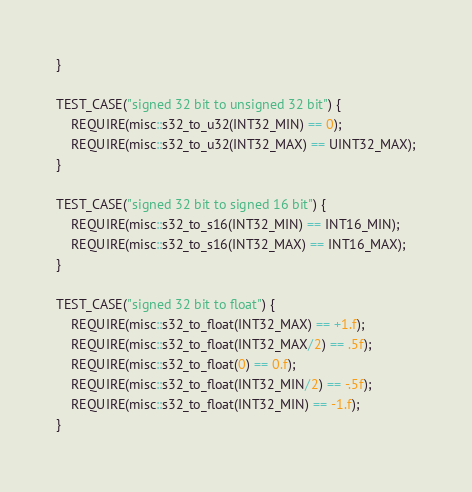<code> <loc_0><loc_0><loc_500><loc_500><_C++_>}

TEST_CASE("signed 32 bit to unsigned 32 bit") {
    REQUIRE(misc::s32_to_u32(INT32_MIN) == 0);
    REQUIRE(misc::s32_to_u32(INT32_MAX) == UINT32_MAX);
}

TEST_CASE("signed 32 bit to signed 16 bit") {
    REQUIRE(misc::s32_to_s16(INT32_MIN) == INT16_MIN);
    REQUIRE(misc::s32_to_s16(INT32_MAX) == INT16_MAX);
}

TEST_CASE("signed 32 bit to float") {
    REQUIRE(misc::s32_to_float(INT32_MAX) == +1.f);
    REQUIRE(misc::s32_to_float(INT32_MAX/2) == .5f);
    REQUIRE(misc::s32_to_float(0) == 0.f);
    REQUIRE(misc::s32_to_float(INT32_MIN/2) == -.5f);
    REQUIRE(misc::s32_to_float(INT32_MIN) == -1.f);
}
</code> 